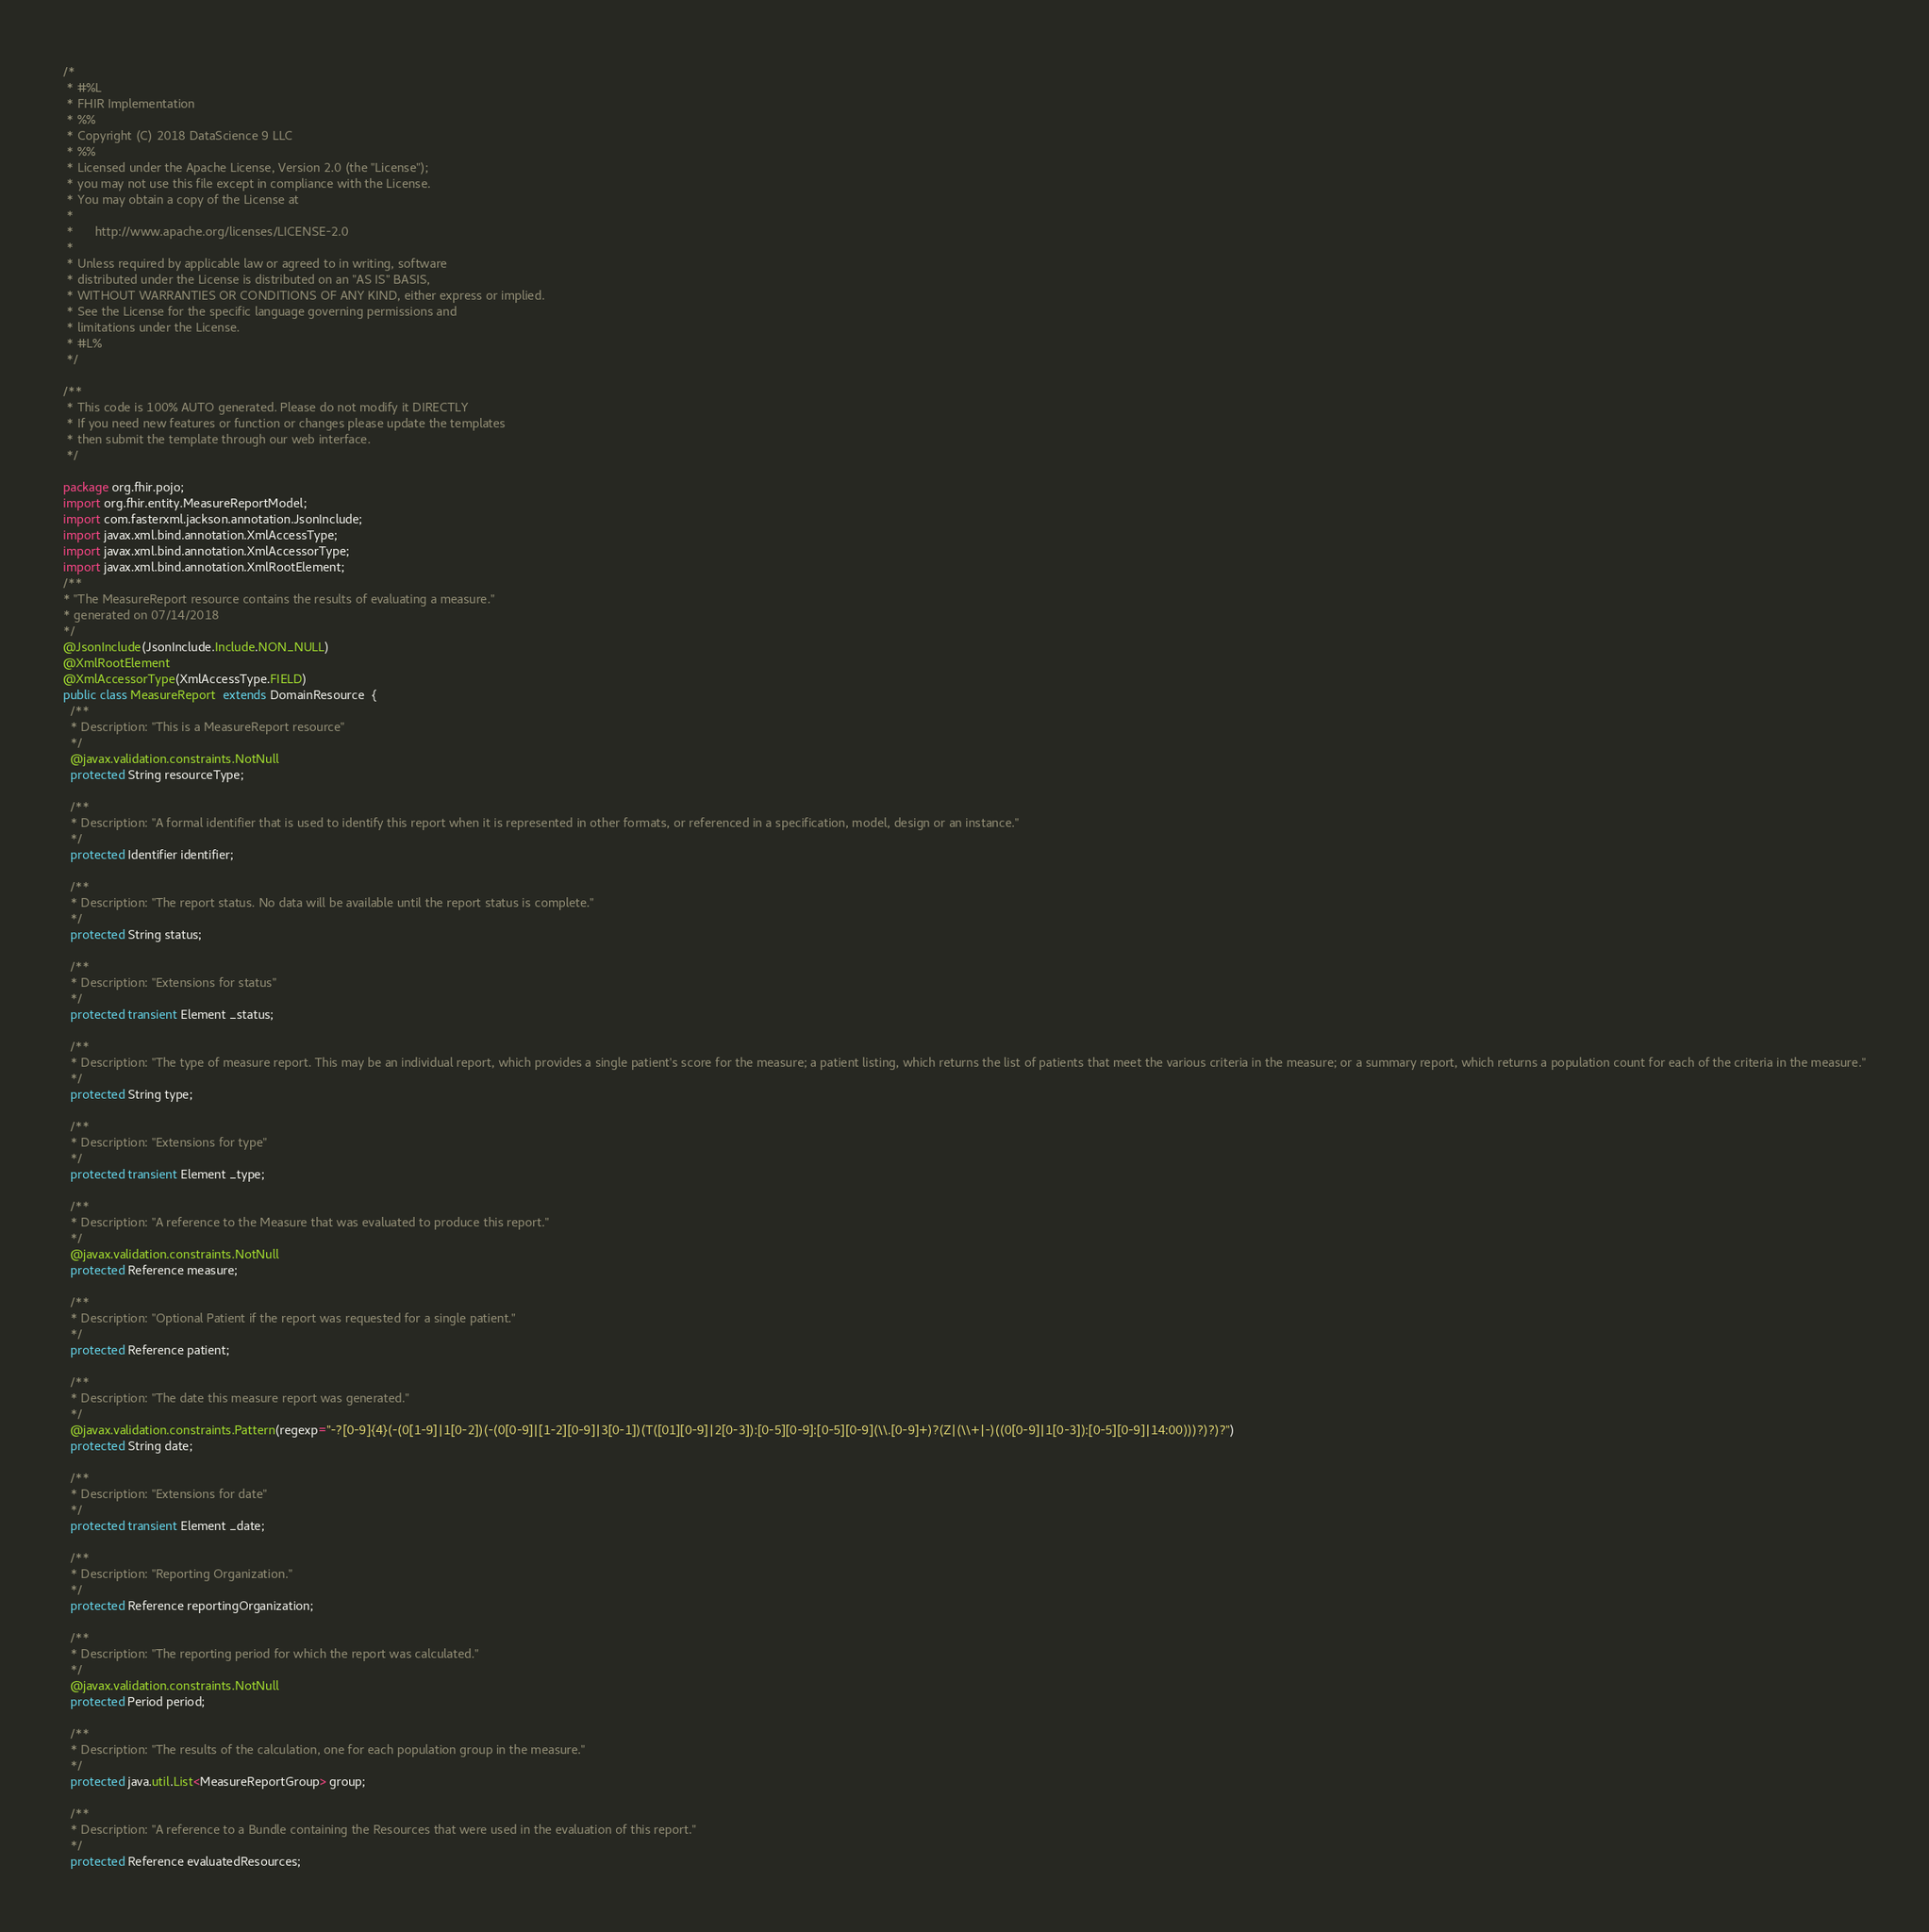<code> <loc_0><loc_0><loc_500><loc_500><_Java_>/*
 * #%L
 * FHIR Implementation
 * %%
 * Copyright (C) 2018 DataScience 9 LLC
 * %%
 * Licensed under the Apache License, Version 2.0 (the "License");
 * you may not use this file except in compliance with the License.
 * You may obtain a copy of the License at
 * 
 *      http://www.apache.org/licenses/LICENSE-2.0
 * 
 * Unless required by applicable law or agreed to in writing, software
 * distributed under the License is distributed on an "AS IS" BASIS,
 * WITHOUT WARRANTIES OR CONDITIONS OF ANY KIND, either express or implied.
 * See the License for the specific language governing permissions and
 * limitations under the License.
 * #L%
 */
 
/**
 * This code is 100% AUTO generated. Please do not modify it DIRECTLY
 * If you need new features or function or changes please update the templates
 * then submit the template through our web interface.  
 */

package org.fhir.pojo;
import org.fhir.entity.MeasureReportModel;
import com.fasterxml.jackson.annotation.JsonInclude;
import javax.xml.bind.annotation.XmlAccessType;
import javax.xml.bind.annotation.XmlAccessorType;
import javax.xml.bind.annotation.XmlRootElement;
/**
* "The MeasureReport resource contains the results of evaluating a measure."
* generated on 07/14/2018
*/
@JsonInclude(JsonInclude.Include.NON_NULL)
@XmlRootElement
@XmlAccessorType(XmlAccessType.FIELD)
public class MeasureReport  extends DomainResource  {
  /**
  * Description: "This is a MeasureReport resource"
  */
  @javax.validation.constraints.NotNull
  protected String resourceType;

  /**
  * Description: "A formal identifier that is used to identify this report when it is represented in other formats, or referenced in a specification, model, design or an instance."
  */
  protected Identifier identifier;

  /**
  * Description: "The report status. No data will be available until the report status is complete."
  */
  protected String status;

  /**
  * Description: "Extensions for status"
  */
  protected transient Element _status;

  /**
  * Description: "The type of measure report. This may be an individual report, which provides a single patient's score for the measure; a patient listing, which returns the list of patients that meet the various criteria in the measure; or a summary report, which returns a population count for each of the criteria in the measure."
  */
  protected String type;

  /**
  * Description: "Extensions for type"
  */
  protected transient Element _type;

  /**
  * Description: "A reference to the Measure that was evaluated to produce this report."
  */
  @javax.validation.constraints.NotNull
  protected Reference measure;

  /**
  * Description: "Optional Patient if the report was requested for a single patient."
  */
  protected Reference patient;

  /**
  * Description: "The date this measure report was generated."
  */
  @javax.validation.constraints.Pattern(regexp="-?[0-9]{4}(-(0[1-9]|1[0-2])(-(0[0-9]|[1-2][0-9]|3[0-1])(T([01][0-9]|2[0-3]):[0-5][0-9]:[0-5][0-9](\\.[0-9]+)?(Z|(\\+|-)((0[0-9]|1[0-3]):[0-5][0-9]|14:00)))?)?)?")
  protected String date;

  /**
  * Description: "Extensions for date"
  */
  protected transient Element _date;

  /**
  * Description: "Reporting Organization."
  */
  protected Reference reportingOrganization;

  /**
  * Description: "The reporting period for which the report was calculated."
  */
  @javax.validation.constraints.NotNull
  protected Period period;

  /**
  * Description: "The results of the calculation, one for each population group in the measure."
  */
  protected java.util.List<MeasureReportGroup> group;

  /**
  * Description: "A reference to a Bundle containing the Resources that were used in the evaluation of this report."
  */
  protected Reference evaluatedResources;
</code> 